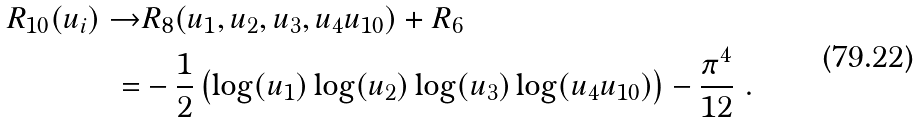<formula> <loc_0><loc_0><loc_500><loc_500>R _ { 1 0 } ( u _ { i } ) \rightarrow & R _ { 8 } ( u _ { 1 } , u _ { 2 } , u _ { 3 } , u _ { 4 } u _ { 1 0 } ) + R _ { 6 } \\ = & - \frac { 1 } { 2 } \left ( \log ( u _ { 1 } ) \log ( u _ { 2 } ) \log ( u _ { 3 } ) \log ( u _ { 4 } u _ { 1 0 } ) \right ) - \frac { \pi ^ { 4 } } { 1 2 } \ .</formula> 